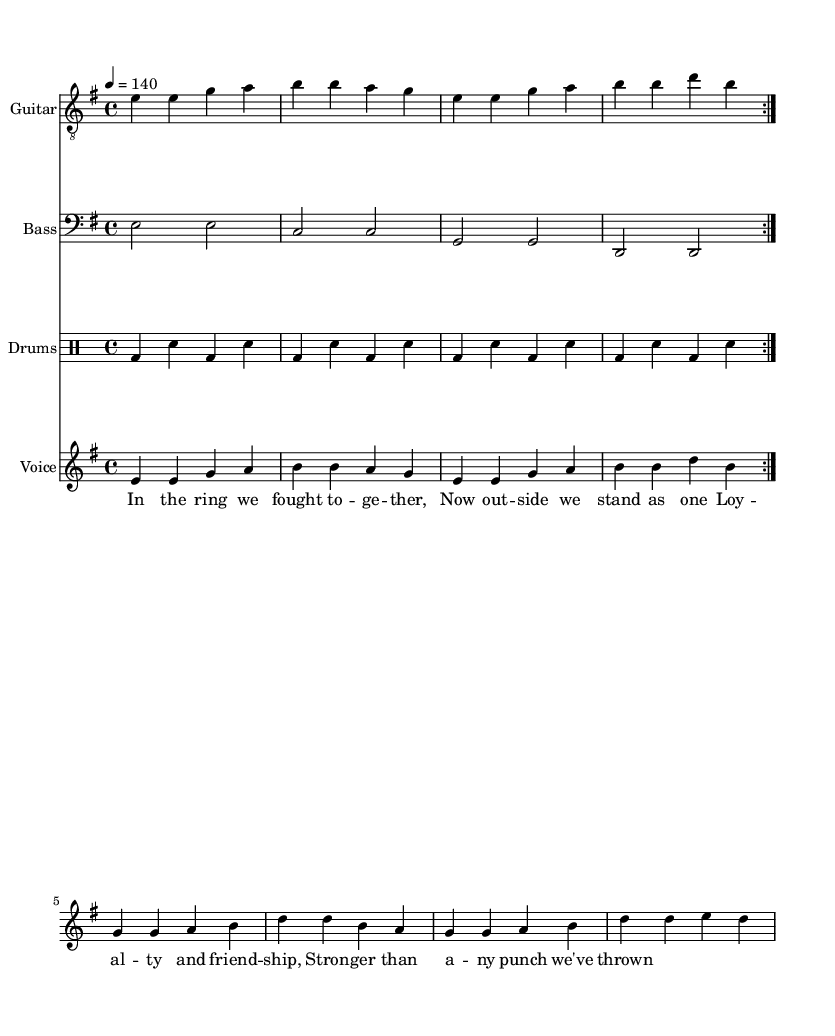What is the key signature of this music? The key signature indicates E minor, which includes one sharp (F#).
Answer: E minor What is the time signature of this music? The time signature shows a 4/4, meaning there are four beats in each measure and the quarter note gets one beat.
Answer: 4/4 What is the tempo marking of this music? The tempo marking is indicated as "4 = 140," which means there are 140 beats per minute.
Answer: 140 How many times is the main music section repeated? The main music section is repeated twice as indicated by the directive "volta 2."
Answer: 2 What is the title of the lyrics theme represented in this music? The lyrics focus on "loyalty and friendship," as clearly stated in the chorus.
Answer: Loyalty and friendship Which instrument is using the bass clef in this score? The instrument assigned to the bass clef is the bass, which typically plays lower pitches.
Answer: Bass In which part of the song is the phrase "In the ring we fought together" found? This phrase appears in the verse section before the chorus, as indicated by the lyrics placement.
Answer: Verse 